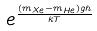<formula> <loc_0><loc_0><loc_500><loc_500>e ^ { \frac { ( m _ { X e } - m _ { H e } ) g h } { k T } }</formula> 